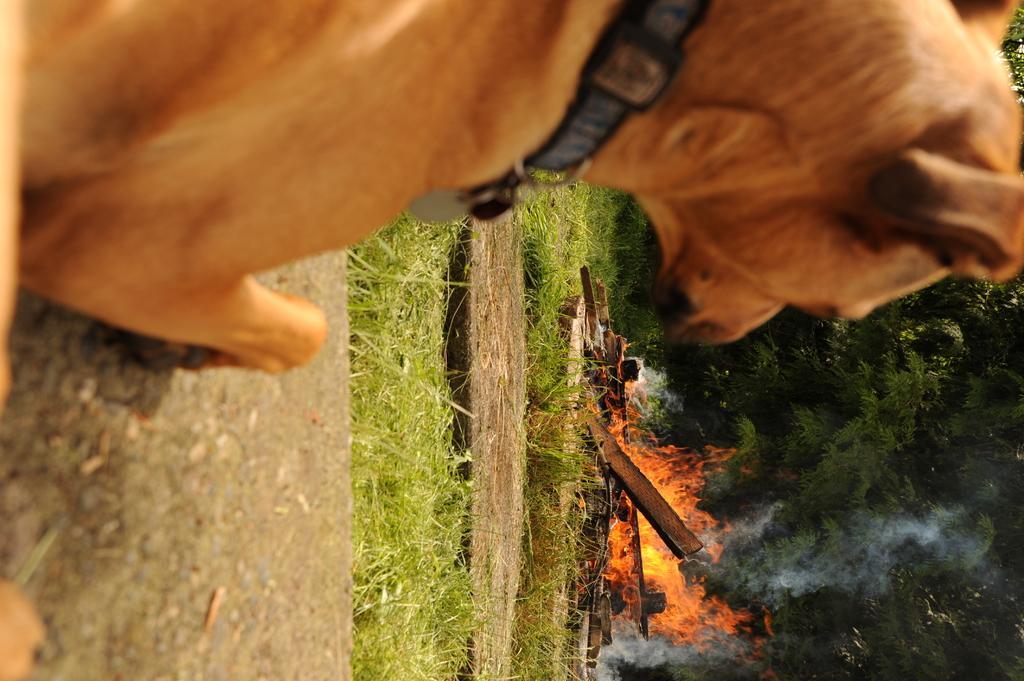Could you give a brief overview of what you see in this image? In this image we can see a dog on the left side. On the right side there is fire and smoke. Also there are trees. On the ground there is grass. 